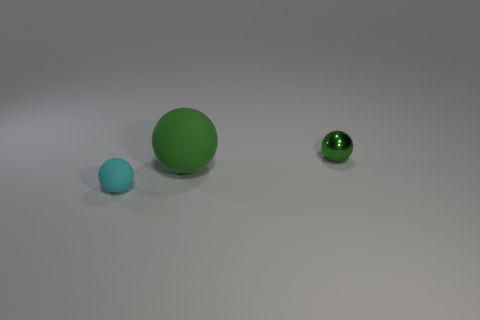Add 2 big things. How many objects exist? 5 Subtract all tiny green things. Subtract all large spheres. How many objects are left? 1 Add 3 big matte balls. How many big matte balls are left? 4 Add 2 tiny metal cylinders. How many tiny metal cylinders exist? 2 Subtract 0 purple balls. How many objects are left? 3 